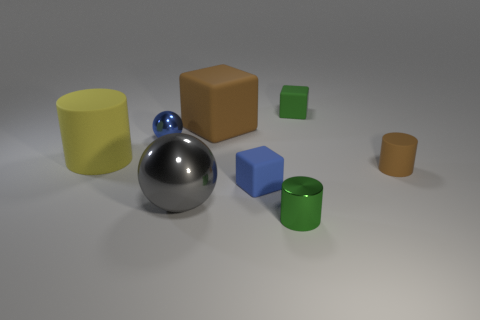Subtract all tiny green blocks. How many blocks are left? 2 Subtract all brown cylinders. How many cylinders are left? 2 Add 1 tiny brown rubber objects. How many objects exist? 9 Subtract 2 blocks. How many blocks are left? 1 Subtract 0 purple blocks. How many objects are left? 8 Subtract all balls. How many objects are left? 6 Subtract all red spheres. Subtract all yellow cylinders. How many spheres are left? 2 Subtract all cyan cubes. How many red spheres are left? 0 Subtract all tiny gray shiny balls. Subtract all small cylinders. How many objects are left? 6 Add 6 big brown blocks. How many big brown blocks are left? 7 